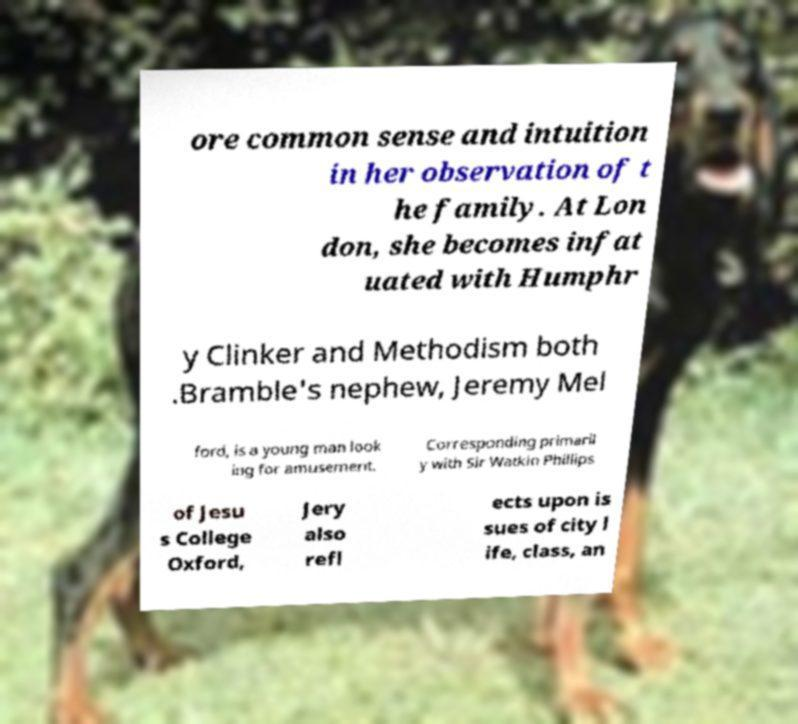Please read and relay the text visible in this image. What does it say? ore common sense and intuition in her observation of t he family. At Lon don, she becomes infat uated with Humphr y Clinker and Methodism both .Bramble's nephew, Jeremy Mel ford, is a young man look ing for amusement. Corresponding primaril y with Sir Watkin Phillips of Jesu s College Oxford, Jery also refl ects upon is sues of city l ife, class, an 